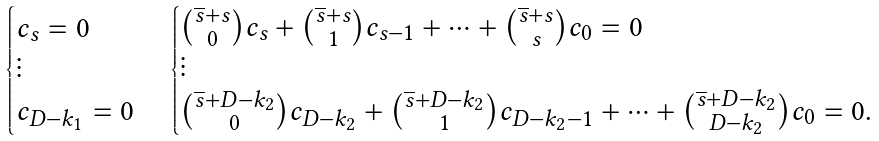Convert formula to latex. <formula><loc_0><loc_0><loc_500><loc_500>\begin{cases} c _ { s } = 0 \\ \vdots \\ c _ { D - k _ { 1 } } = 0 \\ \end{cases} \begin{cases} \binom { \overline { s } + s } { 0 } c _ { s } + \binom { \overline { s } + s } { 1 } c _ { s - 1 } + \cdots + \binom { \overline { s } + s } { s } c _ { 0 } = 0 \\ \vdots \\ \binom { \overline { s } + D - k _ { 2 } } { 0 } c _ { D - k _ { 2 } } + \binom { \overline { s } + D - k _ { 2 } } { 1 } c _ { D - k _ { 2 } - 1 } + \cdots + \binom { \overline { s } + D - k _ { 2 } } { D - k _ { 2 } } c _ { 0 } = 0 . \end{cases}</formula> 